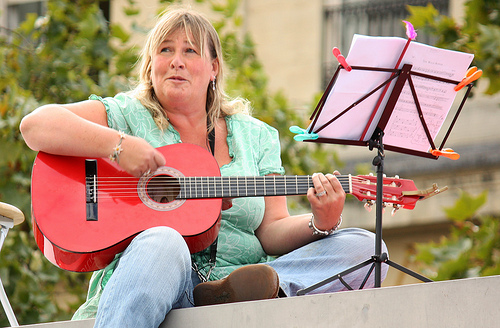<image>
Is there a guitar in front of the sheet music? No. The guitar is not in front of the sheet music. The spatial positioning shows a different relationship between these objects. 